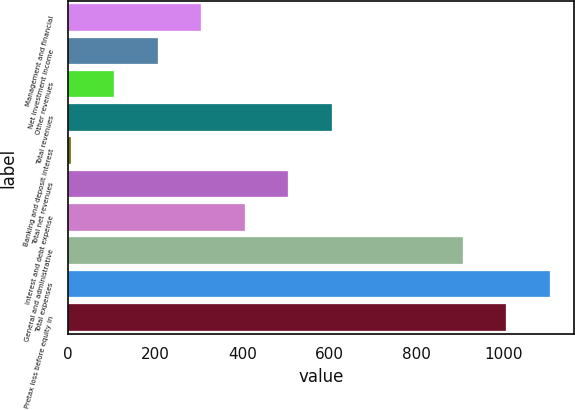Convert chart. <chart><loc_0><loc_0><loc_500><loc_500><bar_chart><fcel>Management and financial<fcel>Net investment income<fcel>Other revenues<fcel>Total revenues<fcel>Banking and deposit interest<fcel>Total net revenues<fcel>Interest and debt expense<fcel>General and administrative<fcel>Total expenses<fcel>Pretax loss before equity in<nl><fcel>306<fcel>206<fcel>106<fcel>606<fcel>6<fcel>506<fcel>406<fcel>906<fcel>1106<fcel>1006<nl></chart> 